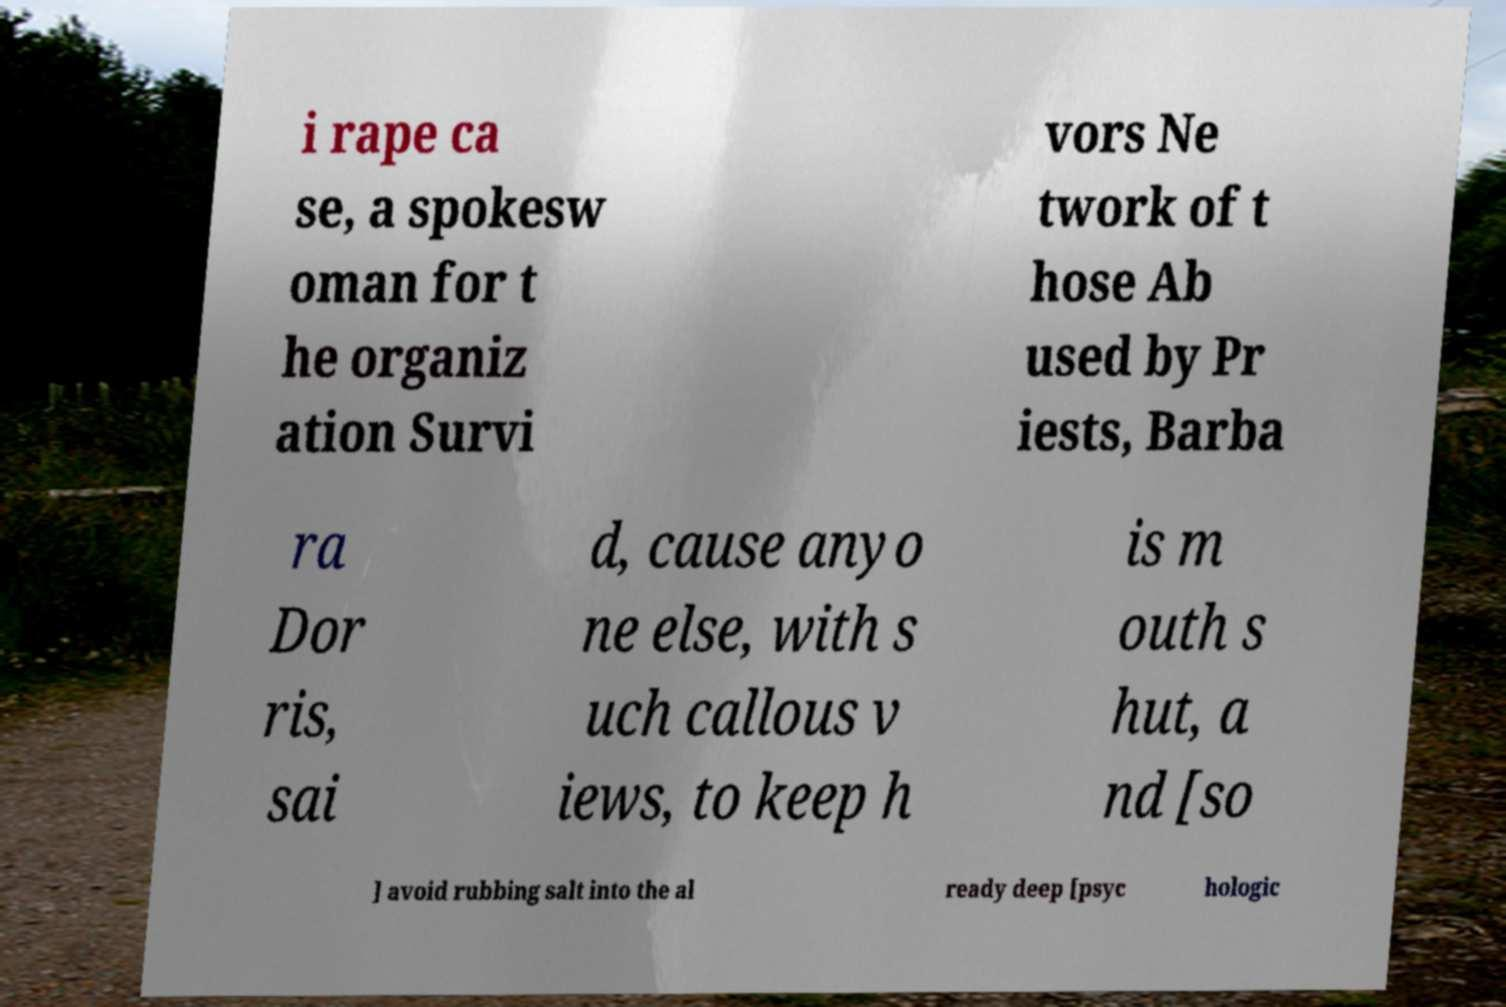Please read and relay the text visible in this image. What does it say? i rape ca se, a spokesw oman for t he organiz ation Survi vors Ne twork of t hose Ab used by Pr iests, Barba ra Dor ris, sai d, cause anyo ne else, with s uch callous v iews, to keep h is m outh s hut, a nd [so ] avoid rubbing salt into the al ready deep [psyc hologic 